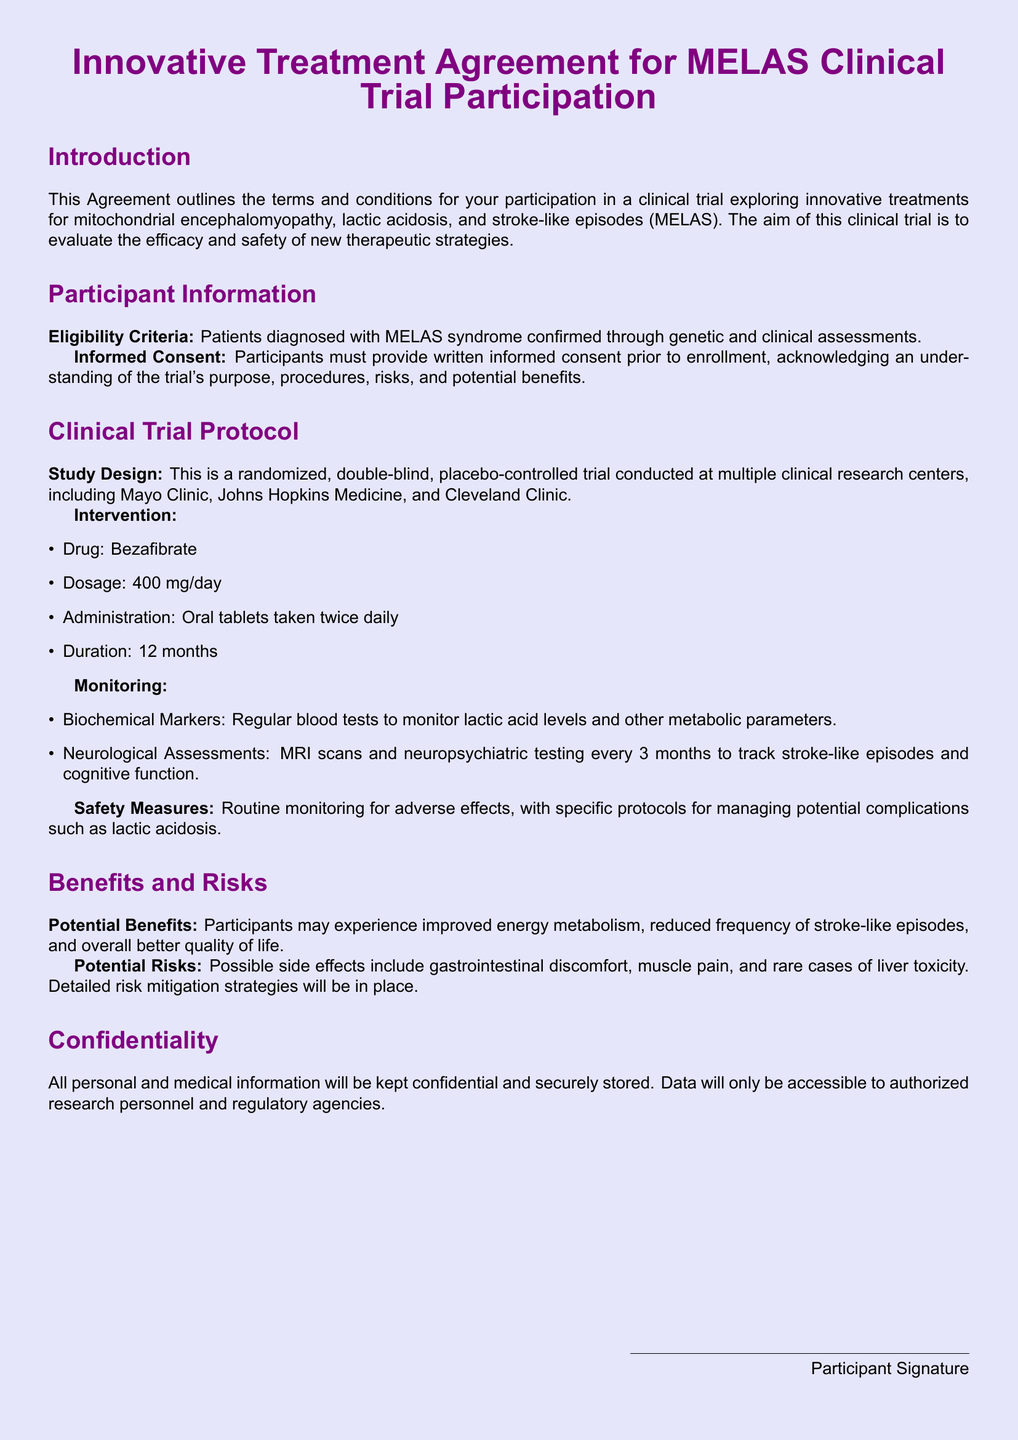What is the title of the agreement? The title of the agreement is the first section of the document.
Answer: Innovative Treatment Agreement for MELAS Clinical Trial Participation What drug is being tested in the trial? The drug tested is mentioned in the intervention section of the document.
Answer: Bezafibrate What is the dosage of the drug? The dosage is specified in the intervention section.
Answer: 400 mg/day How long will the trial last? The duration is clearly stated in the intervention section.
Answer: 12 months What type of trial is being conducted? The study design indicates this type.
Answer: Randomized, double-blind, placebo-controlled What is one of the potential benefits mentioned? Potential benefits are listed in the benefits section.
Answer: Improved energy metabolism What are the routine monitoring procedures? The monitoring methods are outlined in the protocol section.
Answer: Regular blood tests What will participants have to provide before enrollment? This requirement is stated in the informed consent section.
Answer: Written informed consent How often will neurological assessments occur? The frequency of these assessments is detailed in the monitoring section.
Answer: Every 3 months Who will have access to personal and medical information? This detail is mentioned in the confidentiality section.
Answer: Authorized research personnel and regulatory agencies 